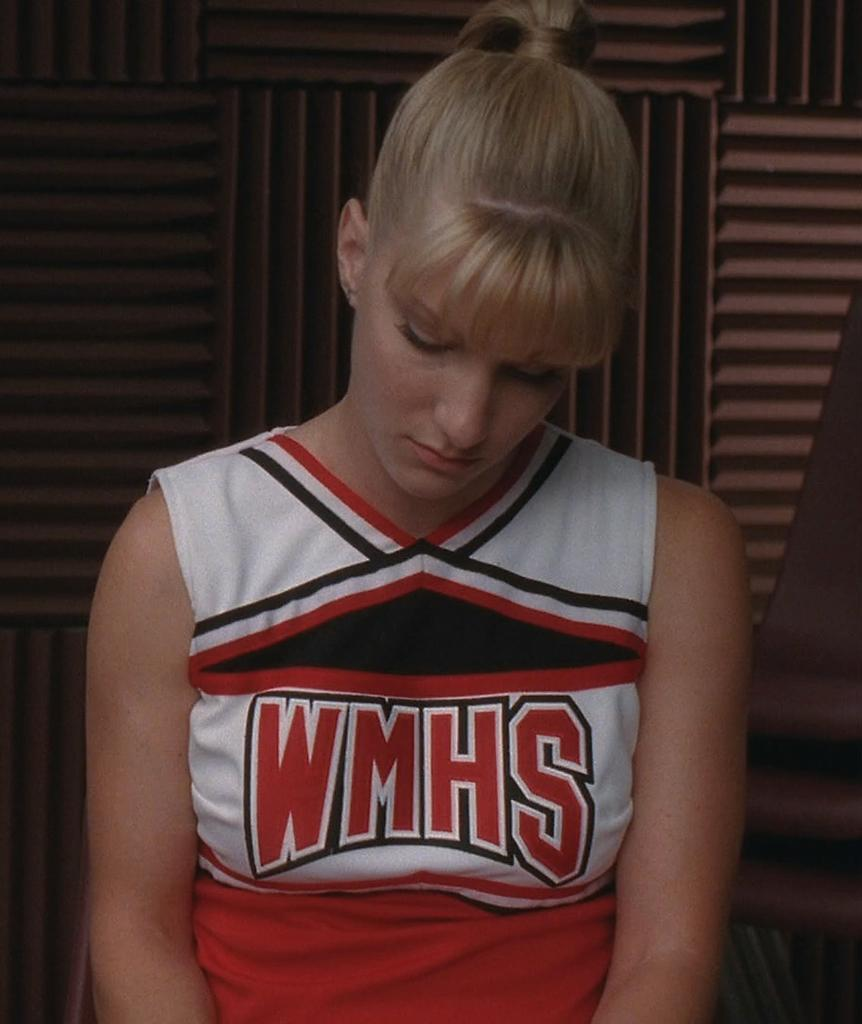<image>
Render a clear and concise summary of the photo. a cheerleader for WMHS in a red, white and black uniform 